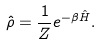Convert formula to latex. <formula><loc_0><loc_0><loc_500><loc_500>\hat { \rho } = \frac { 1 } { Z } e ^ { - \beta \hat { H } } .</formula> 